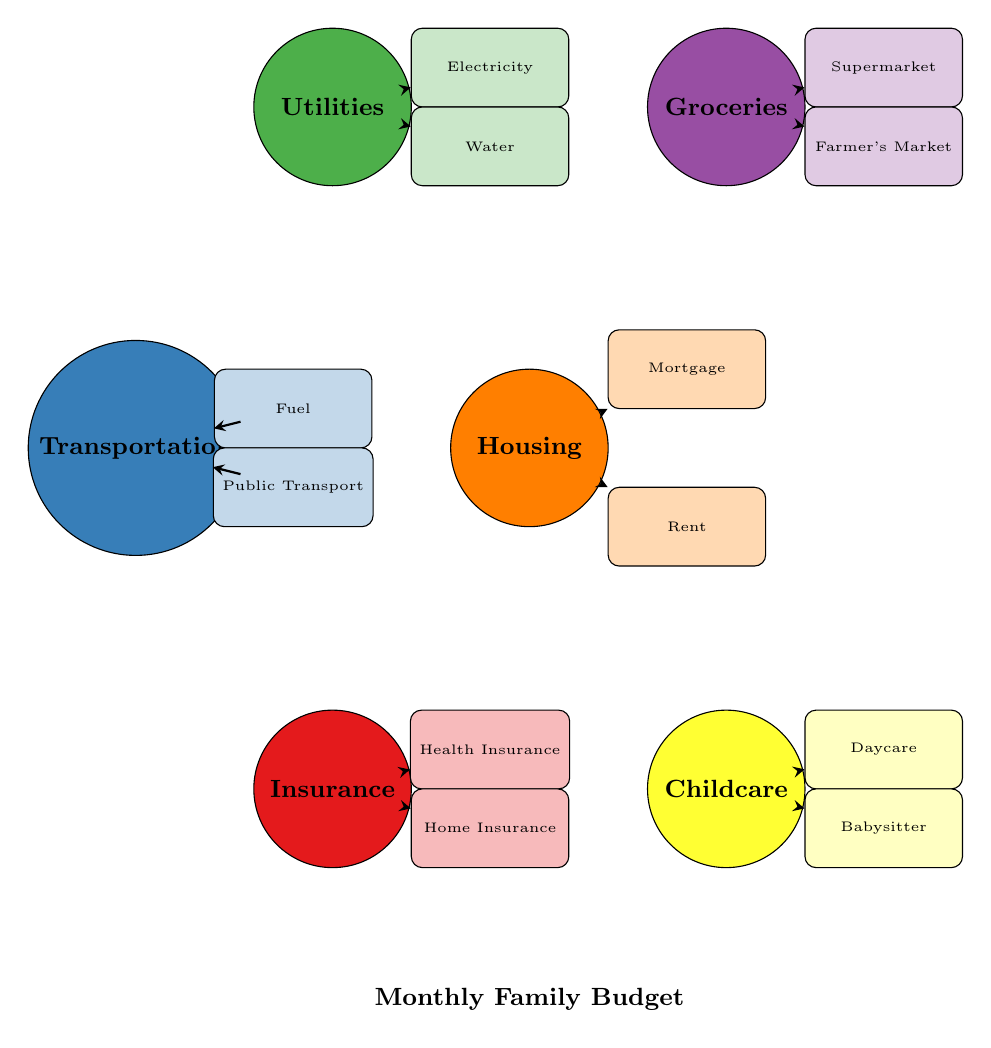What's the total number of main categories in the diagram? The diagram lists the main categories at the outer ring. By counting them, we see there are six main categories: Housing, Groceries, Utilities, Transportation, Insurance, and Childcare.
Answer: 6 Which expense is associated with the Housing category? The Housing category has connections with four expenses: Mortgage, Rent, Property Taxes, and Home Maintenance. One example is Mortgage.
Answer: Mortgage How many subcategories are there under Utilities? From the Utilities category in the diagram, we can identify five subcategories as it connects to Electricity, Water, Gas, Internet, and Phone. Counting these yields a total of five.
Answer: 5 Which category has the most subcategories? To determine this, we need to observe the number of subcategories within each main category. The Education category has four subcategories: Tuition Fees, School Supplies, Books, and Extracurricular Activities. It has the most compared to others like Childcare and Insurance, which have three each.
Answer: Education What is the relationship between the Childcare and Daycare nodes? The Childcare category directly connects to the Daycare subcategory, indicating that Daycare is an expense under the Childcare category. This connection is visually represented in the chord diagram.
Answer: Direct What two transportation methods are included as subcategories under Transportation? Observing the Transportation category, we note that it connects to Fuel and Public Transport as two of its subcategories. These two methods indicate how the family spends on transportation.
Answer: Fuel and Public Transport What is the color coding for the Insurance category? The Insurance category is represented in a specific color, which, per the legend, is the shade representing category five. The color assigned is red.
Answer: Red Which expense under Groceries is from a local source? Among the subcategories listed under Groceries, the Farmer's Market explicitly refers to a local purchasing source for grocery items.
Answer: Farmer's Market 